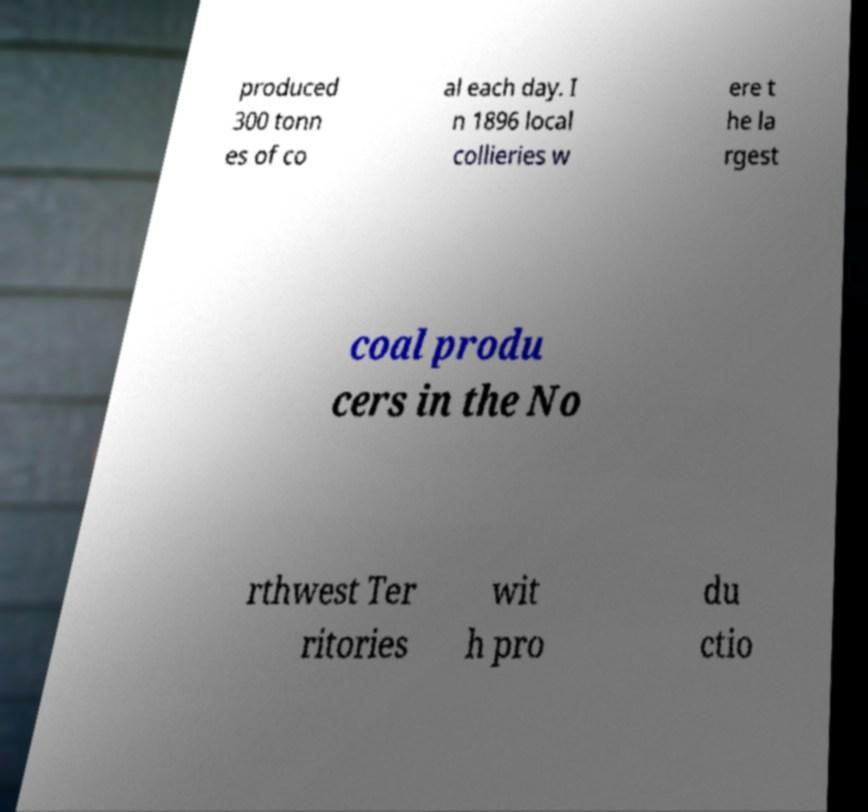Could you extract and type out the text from this image? produced 300 tonn es of co al each day. I n 1896 local collieries w ere t he la rgest coal produ cers in the No rthwest Ter ritories wit h pro du ctio 